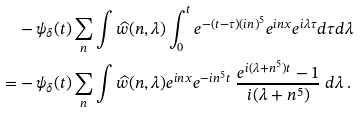Convert formula to latex. <formula><loc_0><loc_0><loc_500><loc_500>& - \psi _ { \delta } ( t ) \sum _ { n } \int \widehat { w } ( n , \lambda ) \int _ { 0 } ^ { t } e ^ { - ( t - \tau ) ( i n ) ^ { 5 } } e ^ { i n x } e ^ { i \lambda \tau } d \tau d \lambda \\ = & - \psi _ { \delta } ( t ) \sum _ { n } \int \widehat { w } ( n , \lambda ) e ^ { i n x } e ^ { - i n ^ { 5 } t } \ \frac { e ^ { i ( \lambda + n ^ { 5 } ) t } - 1 } { i ( \lambda + n ^ { 5 } ) } \ d \lambda \, .</formula> 